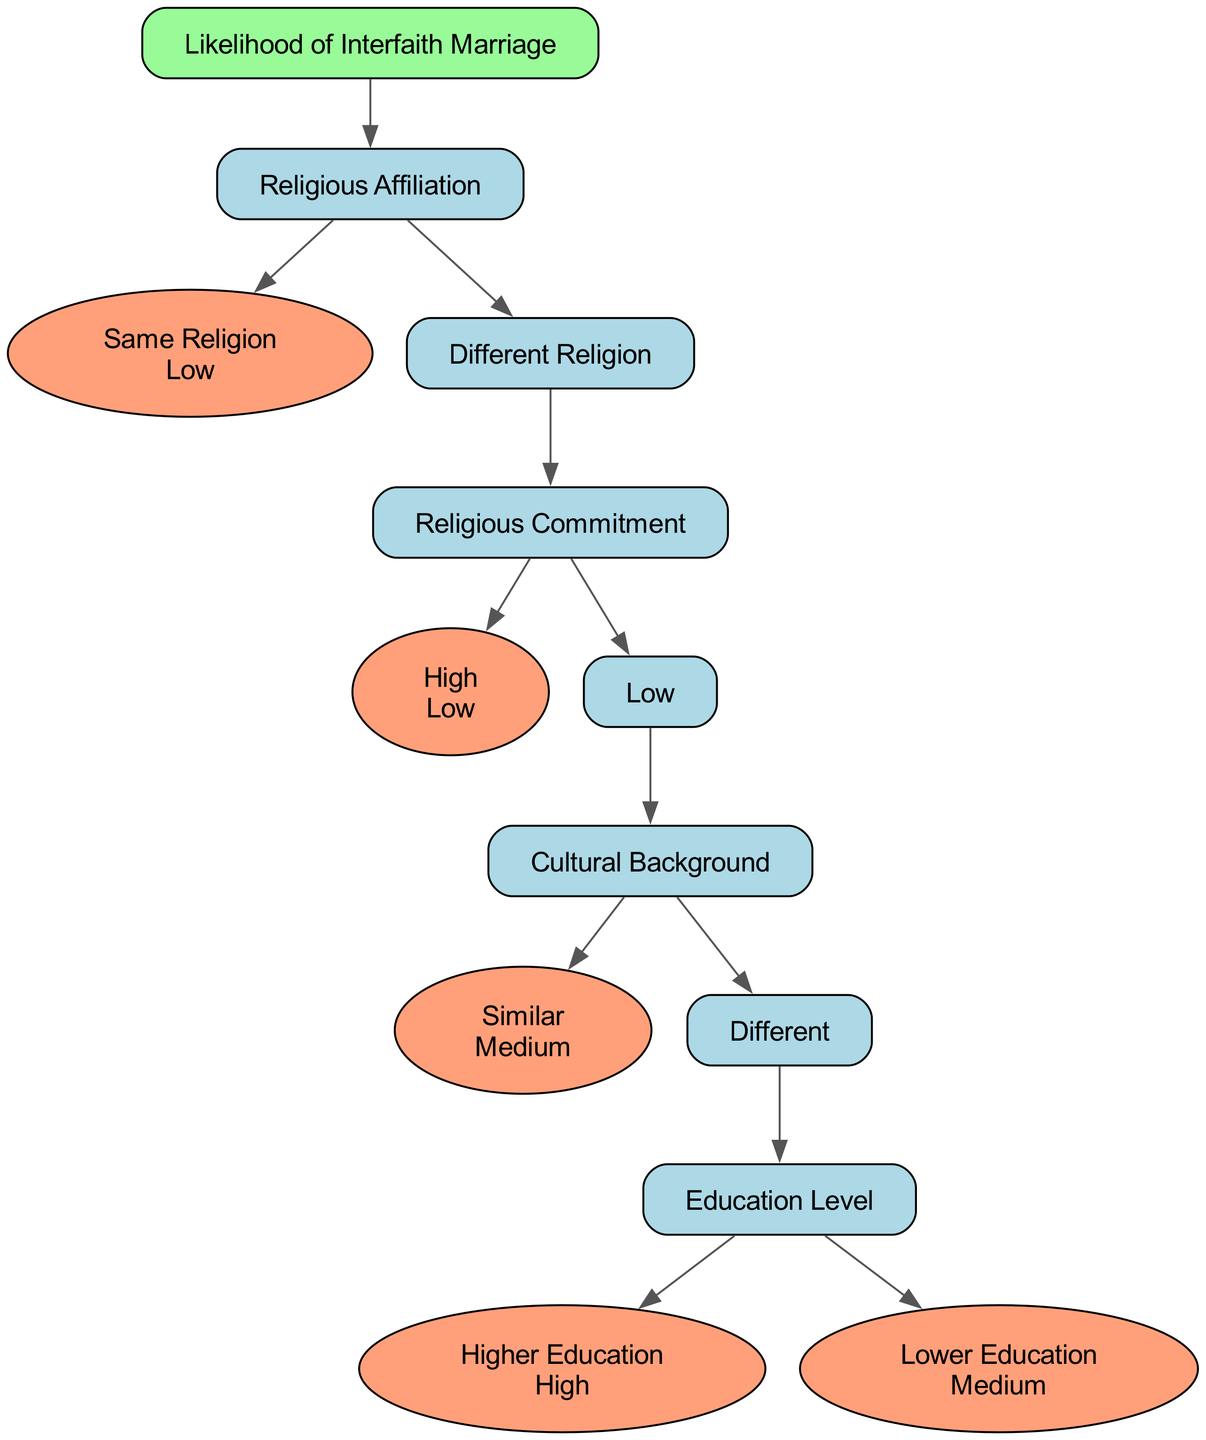What is the value at the "Same Religion" node? The "Same Religion" node directly leads to the value of "Low." This is represented clearly in the diagram as the node specifies this value when following the path from the root.
Answer: Low What is the first decision node after the root? The tree branches from the root "Likelihood of Interfaith Marriage" into "Religious Affiliation." This node serves as the first decision point in the diagram, where the pathway diverges based on the religious backgrounds of individuals.
Answer: Religious Affiliation How many children does the "Different Religion" node have? The "Different Religion" node has two children: "Religious Commitment" and "Cultural Background." Upon examining the diagram, we see these two distinct paths emerging from this decision node, confirming that there are indeed two children.
Answer: 2 What is the value if "Religious Commitment" is Low and "Cultural Background" is Different with "Education Level" as Higher Education? Following the path from the root, we go through "Different Religion" to "Religious Commitment" (Low), leading to "Cultural Background" (Different). From there, we reach "Education Level," which has "Higher Education" as one of its options that points to the value of "High." This illustrates how the presence of higher education influences the likelihood of interfaith marriage positively.
Answer: High What happens to the likelihood of interfaith marriage when "Religious Commitment" is High? When "Religious Commitment" is evaluated as High, the decision tree indicates that it leads directly to a value of "Low." This means that a strong commitment to one's religion significantly reduces the likelihood of interfaith marriage.
Answer: Low What is the value at the "Similar" "Cultural Background" node? At the "Similar" "Cultural Background" node, it leads to the value of "Medium." The diagram clearly states this outcome, signifying that when the cultural backgrounds are similar, the likelihood of interfaith marriages increases to a moderate level.
Answer: Medium What would be the output if both subjects belong to "Different Religion" and have a "Low" "Religious Commitment"? Following the path from the root, we see "Different Religion" leads to "Low" "Religious Commitment," which then leads to another decision point for "Cultural Background." Since this node has further branches, it ultimately leads to more intricate decisions regarding "Cultural Background," but in this context, we know that the path starts with a "Low" likelihood due to the lack of commitment to their religions.
Answer: Medium What is the relationship between "Education Level" and the likelihood of interfaith marriage? "Education Level" affects the likelihood based on its evaluation of being "Higher Education" or "Lower Education." The diagram indicates that "Higher Education" correlates with a "High" likelihood of interfaith marriage, while "Lower Education" results in a "Medium" likelihood. This relationship shows that educational attainment influences the possibility of engaging in interfaith marriages, with higher education fostering more openness.
Answer: High / Medium 